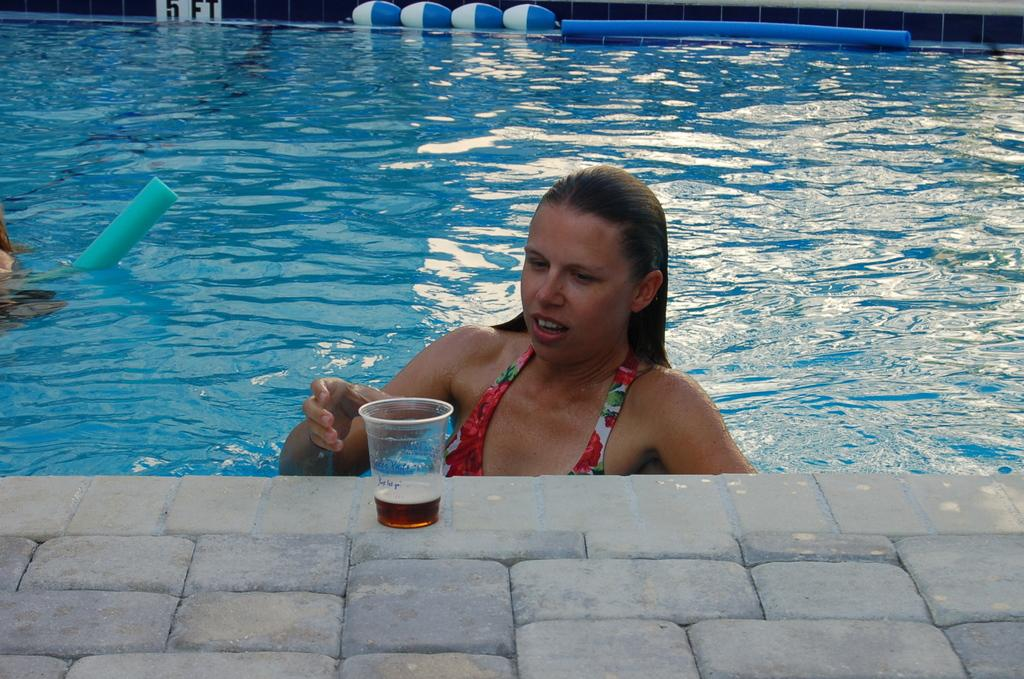What is the woman in the image doing? The woman is in a swimming pool. What can be seen beside the woman in the image? There is a glass with a drink in the image. Can you describe any other objects in the image? There are some objects in the image, but their specific details are not mentioned in the provided facts. What is visible in the background of the image? There is a wall visible in the background of the image. What type of art is displayed on the quilt in the image? There is no quilt or art mentioned in the image, so it's not possible to determine what type of art might be displayed on a quilt. 